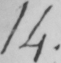Can you read and transcribe this handwriting? 14 . 